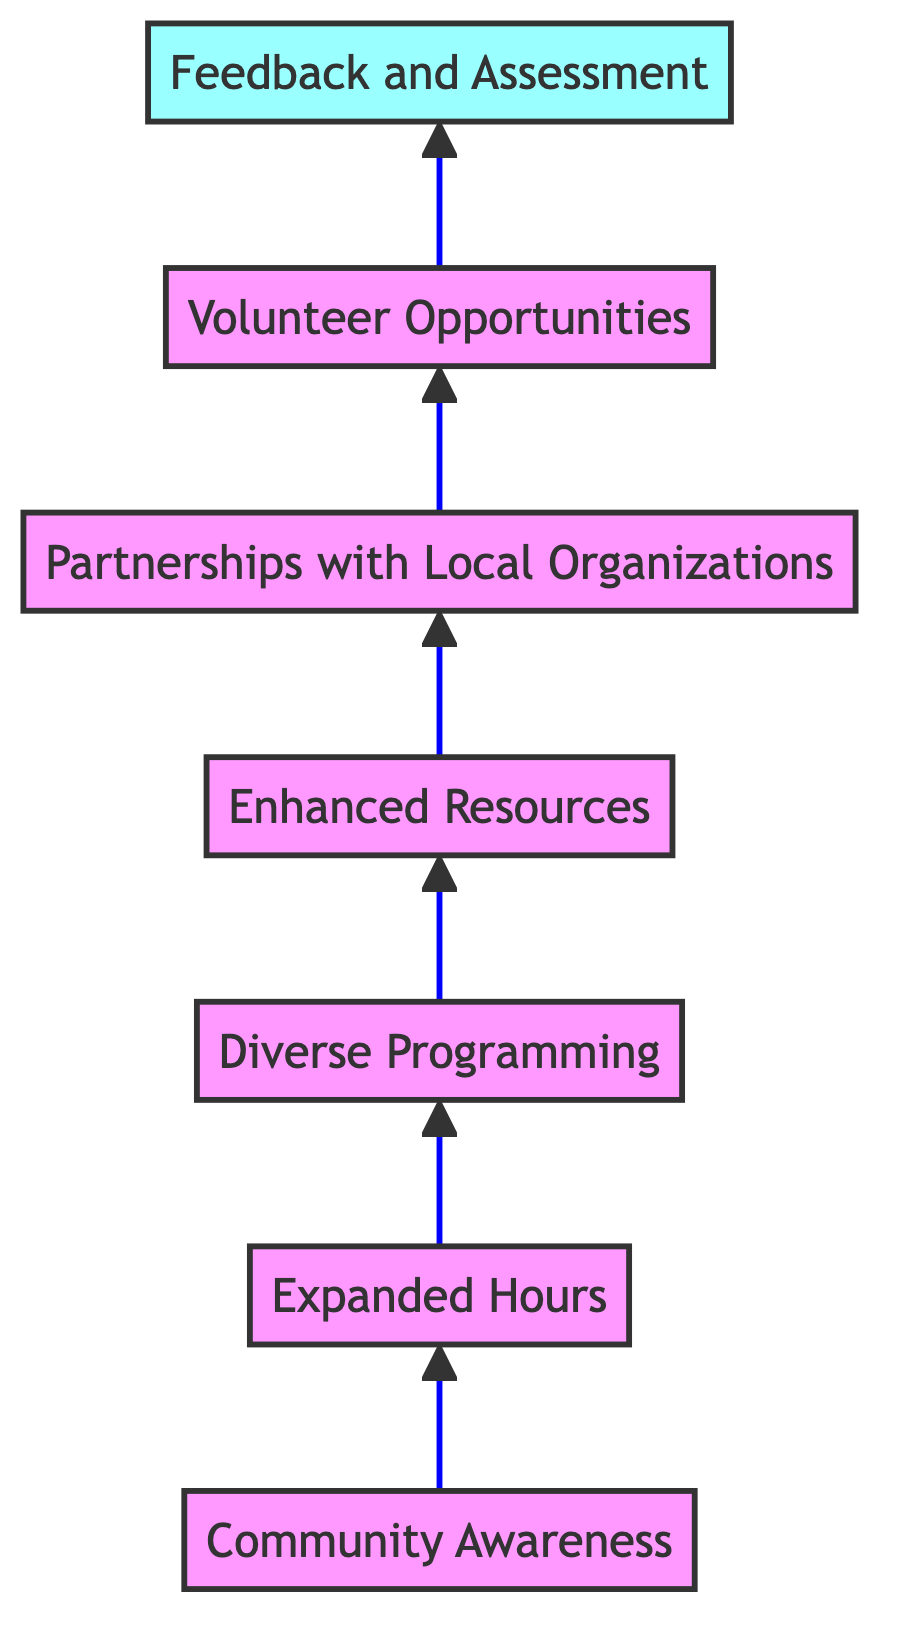What is the highest node in the diagram? The diagram depicts a flow from bottom to top, and the highest node is the one that is at the top of the flow. This is "Feedback and Assessment."
Answer: Feedback and Assessment How many total nodes are in the diagram? To find the total number of nodes, we count each of the elements defined in the data: Community Awareness, Expanded Hours, Diverse Programming, Enhanced Resources, Partnerships with Local Organizations, Volunteer Opportunities, and Feedback and Assessment. There are 7 nodes in total.
Answer: 7 What is the relationship between "Diverse Programming" and "Enhanced Resources"? In the diagram, "Diverse Programming" leads to "Enhanced Resources," indicating that the implementation of diverse programming is a step toward enhancing the resources available at the library.
Answer: Leads to Which node comes directly after "Expanded Hours"? The node that comes directly after "Expanded Hours" in the flow is "Diverse Programming." This is evident as we can trace the arrows pointing upward from "Expanded Hours."
Answer: Diverse Programming What is the last node in the flow? The last node in the flow is determined by locating the node at the top of the diagram. The last node, in this case, is "Feedback and Assessment."
Answer: Feedback and Assessment Which nodes contribute to community engagement before "Volunteer Opportunities"? To find the nodes contributing to community engagement before "Volunteer Opportunities," we observe the nodes leading up to it. These are "Community Awareness," "Expanded Hours," "Diverse Programming," and "Enhanced Resources."
Answer: Community Awareness, Expanded Hours, Diverse Programming, Enhanced Resources What is the first step in increasing community engagement according to the diagram? The first step in increasing community engagement is represented by the first node at the bottom of the diagram, which is "Community Awareness."
Answer: Community Awareness How many edges are in the diagram? The edges are the connections between the nodes. To determine the count, we can follow the arrows from one node to the next. There are 6 connections in total: from Community Awareness to Expanded Hours, Expanded Hours to Diverse Programming, Diverse Programming to Enhanced Resources, Enhanced Resources to Partnerships with Local Organizations, Partnerships with Local Organizations to Volunteer Opportunities, and Volunteer Opportunities to Feedback and Assessment.
Answer: 6 